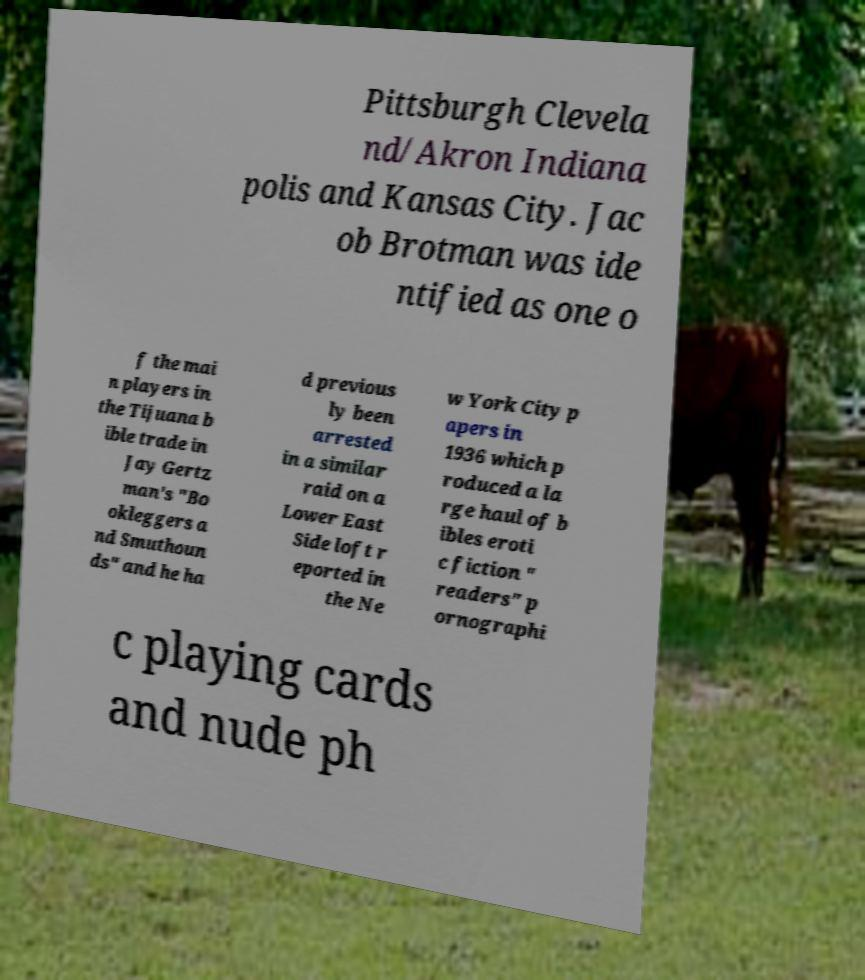Please read and relay the text visible in this image. What does it say? Pittsburgh Clevela nd/Akron Indiana polis and Kansas City. Jac ob Brotman was ide ntified as one o f the mai n players in the Tijuana b ible trade in Jay Gertz man's "Bo okleggers a nd Smuthoun ds" and he ha d previous ly been arrested in a similar raid on a Lower East Side loft r eported in the Ne w York City p apers in 1936 which p roduced a la rge haul of b ibles eroti c fiction " readers" p ornographi c playing cards and nude ph 